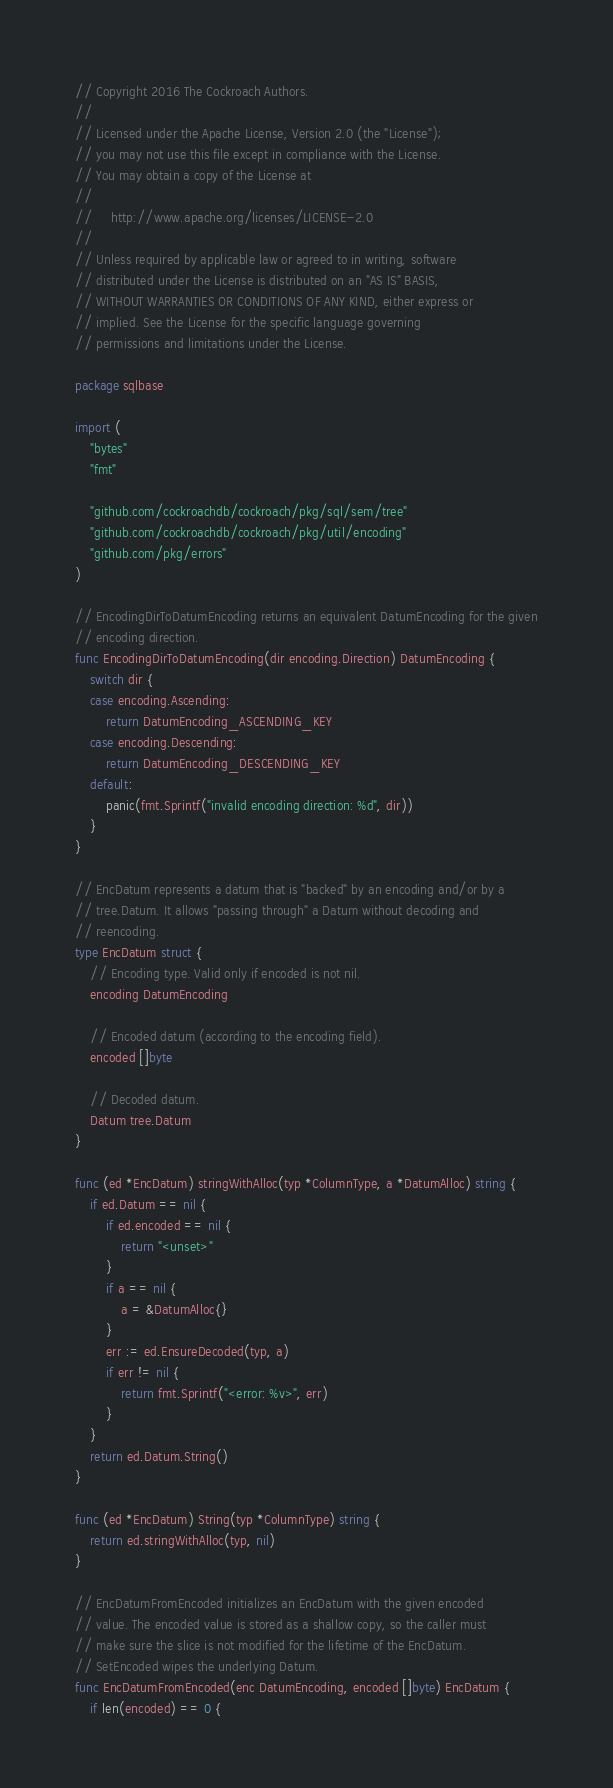<code> <loc_0><loc_0><loc_500><loc_500><_Go_>// Copyright 2016 The Cockroach Authors.
//
// Licensed under the Apache License, Version 2.0 (the "License");
// you may not use this file except in compliance with the License.
// You may obtain a copy of the License at
//
//     http://www.apache.org/licenses/LICENSE-2.0
//
// Unless required by applicable law or agreed to in writing, software
// distributed under the License is distributed on an "AS IS" BASIS,
// WITHOUT WARRANTIES OR CONDITIONS OF ANY KIND, either express or
// implied. See the License for the specific language governing
// permissions and limitations under the License.

package sqlbase

import (
	"bytes"
	"fmt"

	"github.com/cockroachdb/cockroach/pkg/sql/sem/tree"
	"github.com/cockroachdb/cockroach/pkg/util/encoding"
	"github.com/pkg/errors"
)

// EncodingDirToDatumEncoding returns an equivalent DatumEncoding for the given
// encoding direction.
func EncodingDirToDatumEncoding(dir encoding.Direction) DatumEncoding {
	switch dir {
	case encoding.Ascending:
		return DatumEncoding_ASCENDING_KEY
	case encoding.Descending:
		return DatumEncoding_DESCENDING_KEY
	default:
		panic(fmt.Sprintf("invalid encoding direction: %d", dir))
	}
}

// EncDatum represents a datum that is "backed" by an encoding and/or by a
// tree.Datum. It allows "passing through" a Datum without decoding and
// reencoding.
type EncDatum struct {
	// Encoding type. Valid only if encoded is not nil.
	encoding DatumEncoding

	// Encoded datum (according to the encoding field).
	encoded []byte

	// Decoded datum.
	Datum tree.Datum
}

func (ed *EncDatum) stringWithAlloc(typ *ColumnType, a *DatumAlloc) string {
	if ed.Datum == nil {
		if ed.encoded == nil {
			return "<unset>"
		}
		if a == nil {
			a = &DatumAlloc{}
		}
		err := ed.EnsureDecoded(typ, a)
		if err != nil {
			return fmt.Sprintf("<error: %v>", err)
		}
	}
	return ed.Datum.String()
}

func (ed *EncDatum) String(typ *ColumnType) string {
	return ed.stringWithAlloc(typ, nil)
}

// EncDatumFromEncoded initializes an EncDatum with the given encoded
// value. The encoded value is stored as a shallow copy, so the caller must
// make sure the slice is not modified for the lifetime of the EncDatum.
// SetEncoded wipes the underlying Datum.
func EncDatumFromEncoded(enc DatumEncoding, encoded []byte) EncDatum {
	if len(encoded) == 0 {</code> 